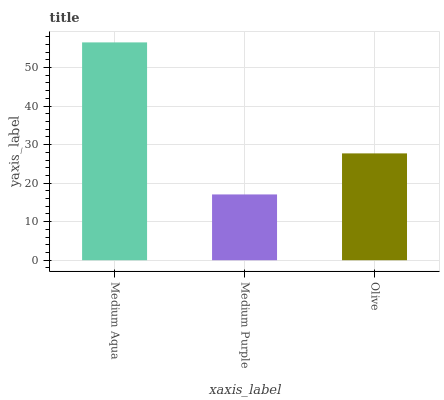Is Medium Purple the minimum?
Answer yes or no. Yes. Is Medium Aqua the maximum?
Answer yes or no. Yes. Is Olive the minimum?
Answer yes or no. No. Is Olive the maximum?
Answer yes or no. No. Is Olive greater than Medium Purple?
Answer yes or no. Yes. Is Medium Purple less than Olive?
Answer yes or no. Yes. Is Medium Purple greater than Olive?
Answer yes or no. No. Is Olive less than Medium Purple?
Answer yes or no. No. Is Olive the high median?
Answer yes or no. Yes. Is Olive the low median?
Answer yes or no. Yes. Is Medium Aqua the high median?
Answer yes or no. No. Is Medium Purple the low median?
Answer yes or no. No. 